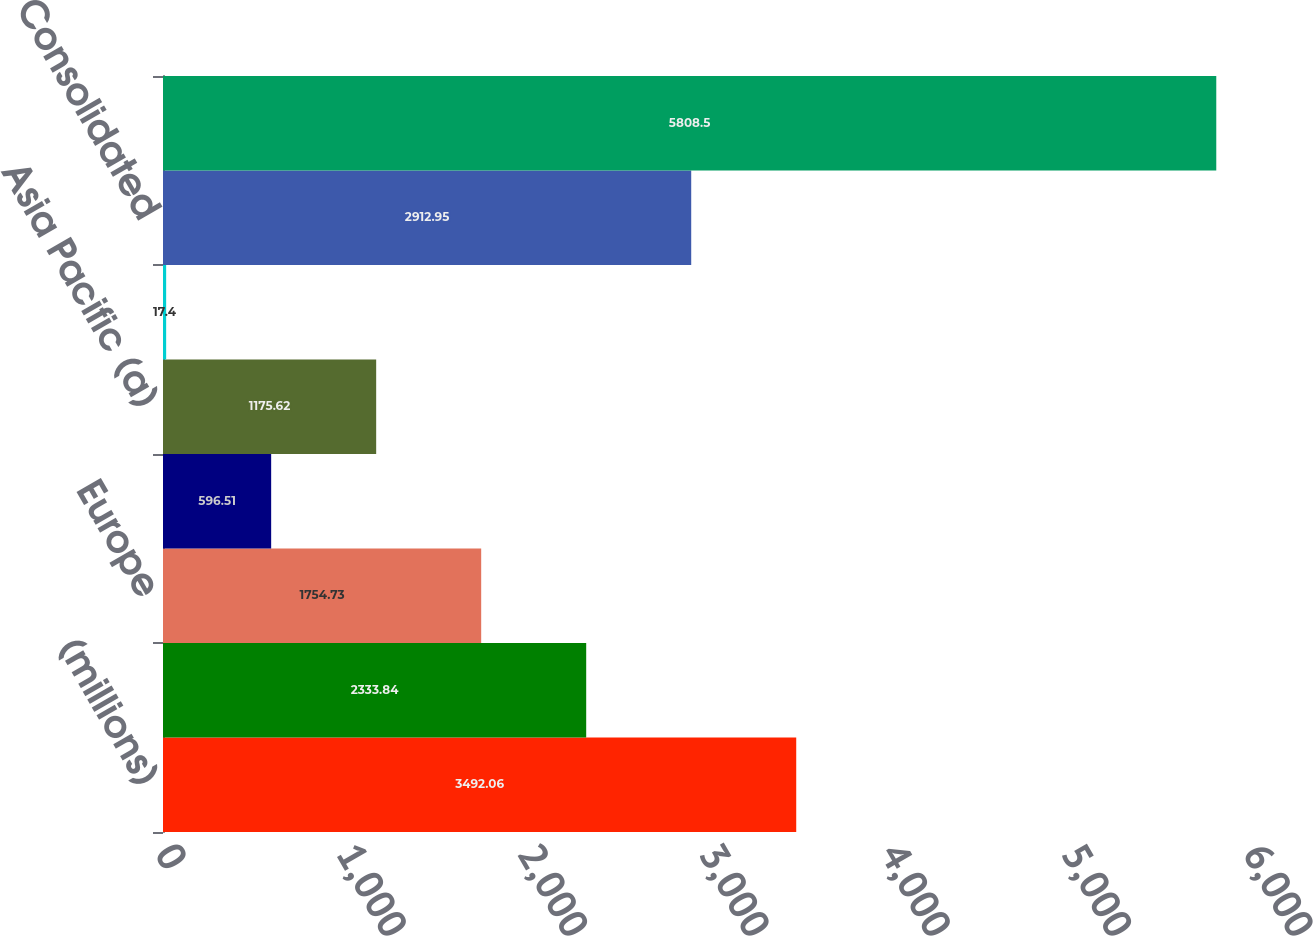Convert chart. <chart><loc_0><loc_0><loc_500><loc_500><bar_chart><fcel>(millions)<fcel>North America<fcel>Europe<fcel>Latin America<fcel>Asia Pacific (a)<fcel>Corporate<fcel>Consolidated<fcel>Elimination entries<nl><fcel>3492.06<fcel>2333.84<fcel>1754.73<fcel>596.51<fcel>1175.62<fcel>17.4<fcel>2912.95<fcel>5808.5<nl></chart> 